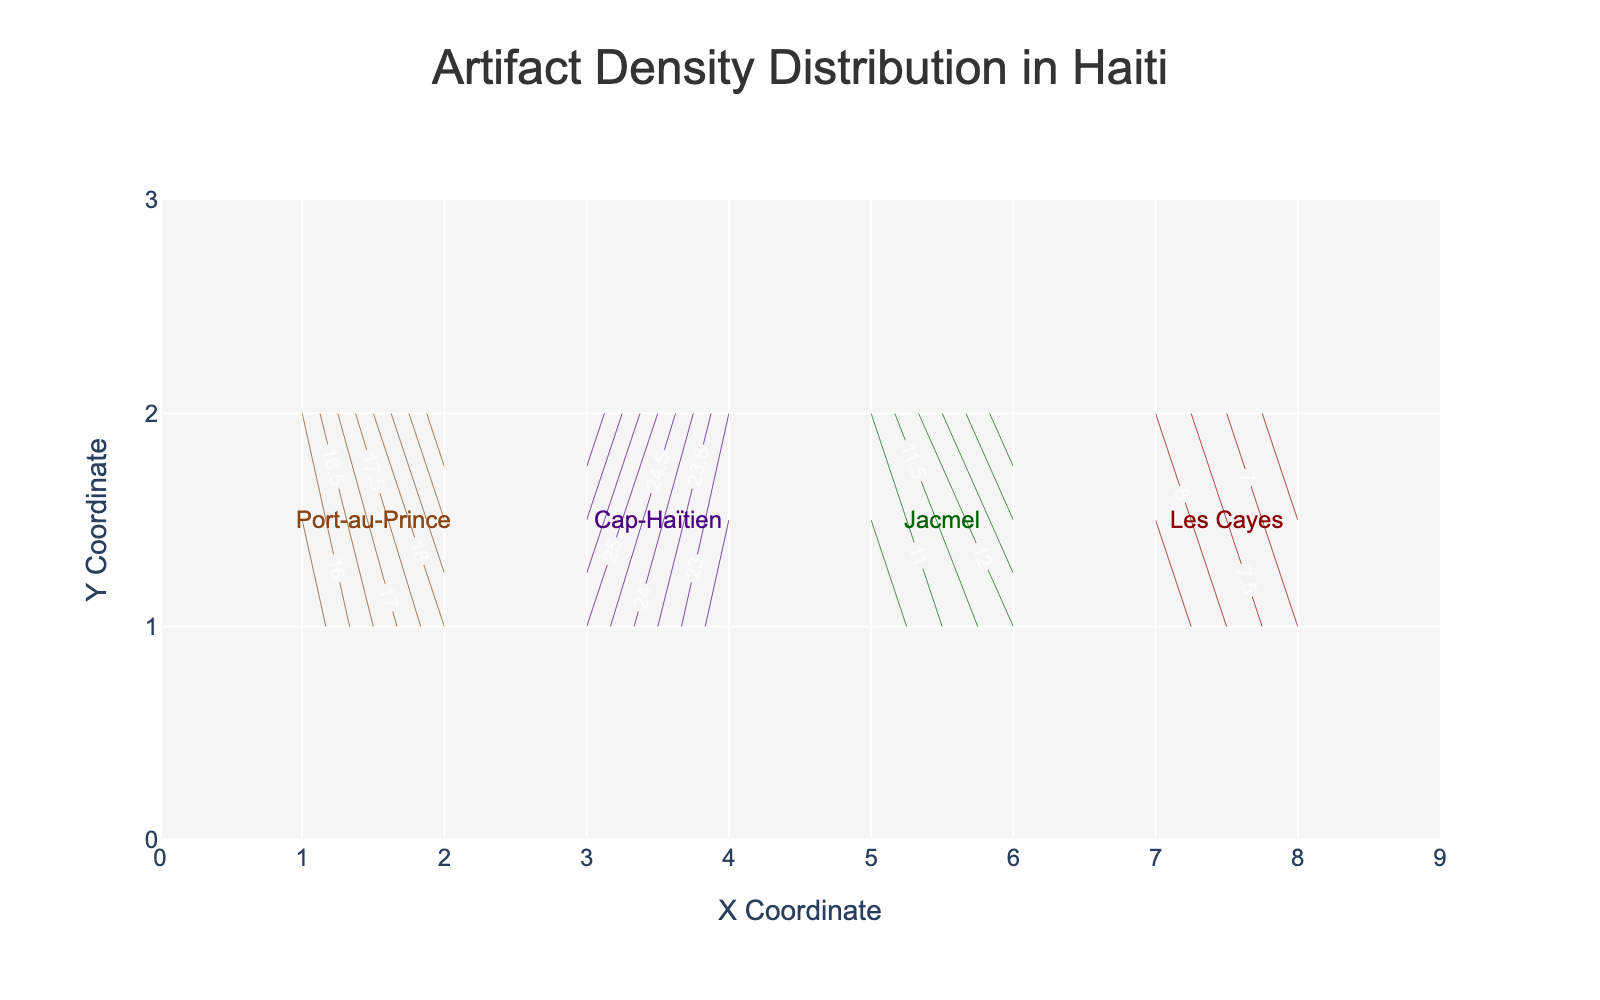What's the title of the figure? The title of the figure is located at the top of the chart. It gives a brief description of what the figure is about.
Answer: Artifact Density Distribution in Haiti What are the axes' labels? The x-axis label is "X Coordinate" and the y-axis label is "Y Coordinate," which can be observed along the respective axes.
Answer: X Coordinate, Y Coordinate Which excavation zone has the highest artifact density? The Cap-Haïtien Zone has the highest artifact density as its contour lines are around the higher values (shown in 25 and 27 units), evident by the highest labeled density values on the plot.
Answer: Cap-Haïtien Zone Where is the artifact density highest in the Les Cayes Zone? The highest artifact density in the Les Cayes Zone is at the coordinate (7, 1) with an artifact density value of 9. The density values are labeled on the contour lines.
Answer: (7, 1), 9 How many different colors are used in the plot to represent the zones? Four colors are used in the plot, representing each of the four excavation zones: Port-au-Prince, Cap-Haïtien, Jacmel, and Les Cayes. The colors can be seen in the contour lines and the annotations.
Answer: Four Which excavation zone shows the lowest artifact density? Les Cayes Zone shows the lowest artifact densities with values being below 10, specifically coordinates with values 7, 8, and 6. This is evident by comparing the density labels on the contour lines of each zone.
Answer: Les Cayes Zone Compare the artifact densities between Port-au-Prince and Jacmel zones. Which one has higher artifact densities on average? To compare, examine the density values in each zone. Port-au-Prince has densities of 15, 16, 18, and 20. Jacmel has densities of 10, 11, 12, and 14. Calculating the average: Port-au-Prince (15+16+18+20)/4 = 17.25 and Jacmel (10+11+12+14)/4 = 11.75. Therefore, Port-au-Prince has higher artifact densities on average.
Answer: Port-au-Prince What is the artifact density at coordinate (2, 2)? The density value at coordinate (2, 2) can be found by looking at the labeling within the contour lines. It is part of the Port-au-Prince Zone, and the value is 20.
Answer: 20 What general trend can be observed about artifact density from Cap-Haïtien zone compared to Jacmel zone? The general trend shows that Cap-Haïtien Zone has higher artifact densities with values like 25, 22, 27, 23, whereas Jacmel Zone has lower values like 10, 12, 11, 14. This trend can be observed from the labeled values in the contour lines of each zone.
Answer: Cap-Haïtien has higher artifact densities 